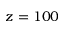Convert formula to latex. <formula><loc_0><loc_0><loc_500><loc_500>z = 1 0 0</formula> 